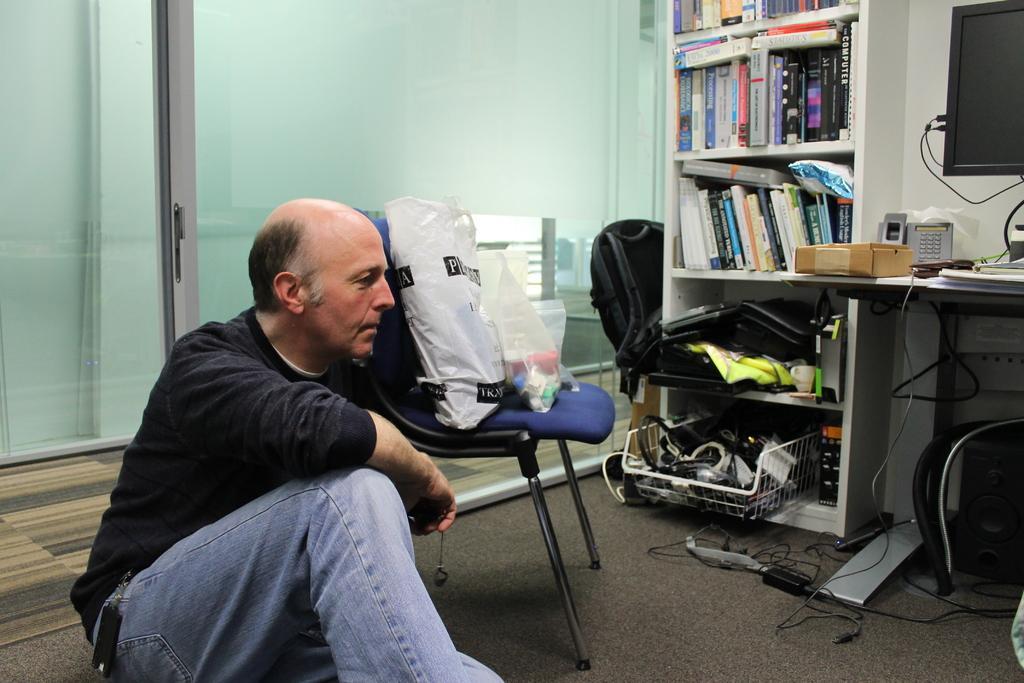In one or two sentences, can you explain what this image depicts? In this image we can see a person sitting on the floor, there are covers on the chair, there are some books, boxes some objects on the racks, there are some objects on in a tray, there is a bag, there is a table, on that there is a monitor, box, telephone, and some other objects, there are wires on the floor, also we can see the wall, and a door. 